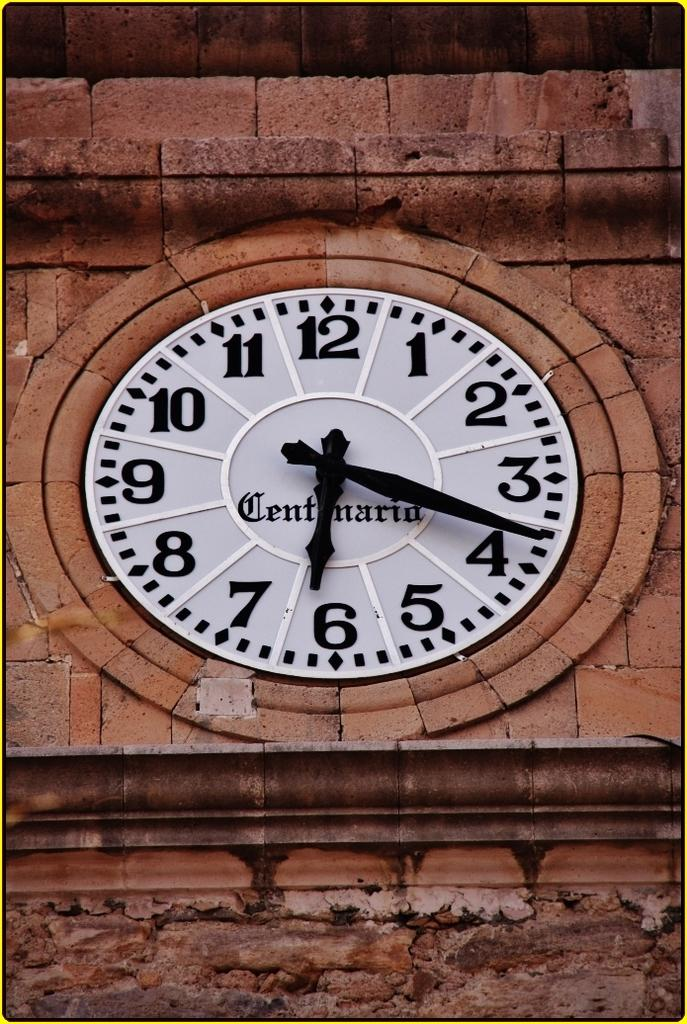Provide a one-sentence caption for the provided image. A large clock surrounded by stone reads 6:18 on its face. 